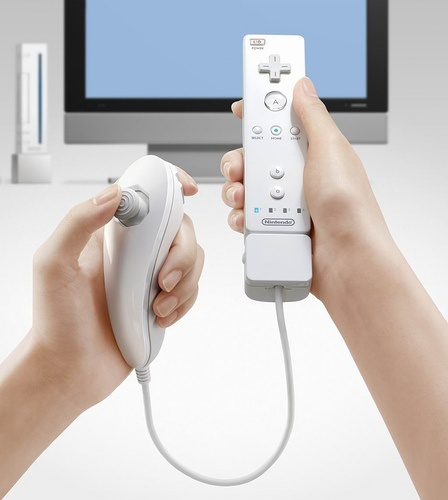Describe the objects in this image and their specific colors. I can see people in lightgray and tan tones, tv in lightgray, lightblue, darkgray, black, and gray tones, and remote in lightgray, white, darkgray, and gray tones in this image. 